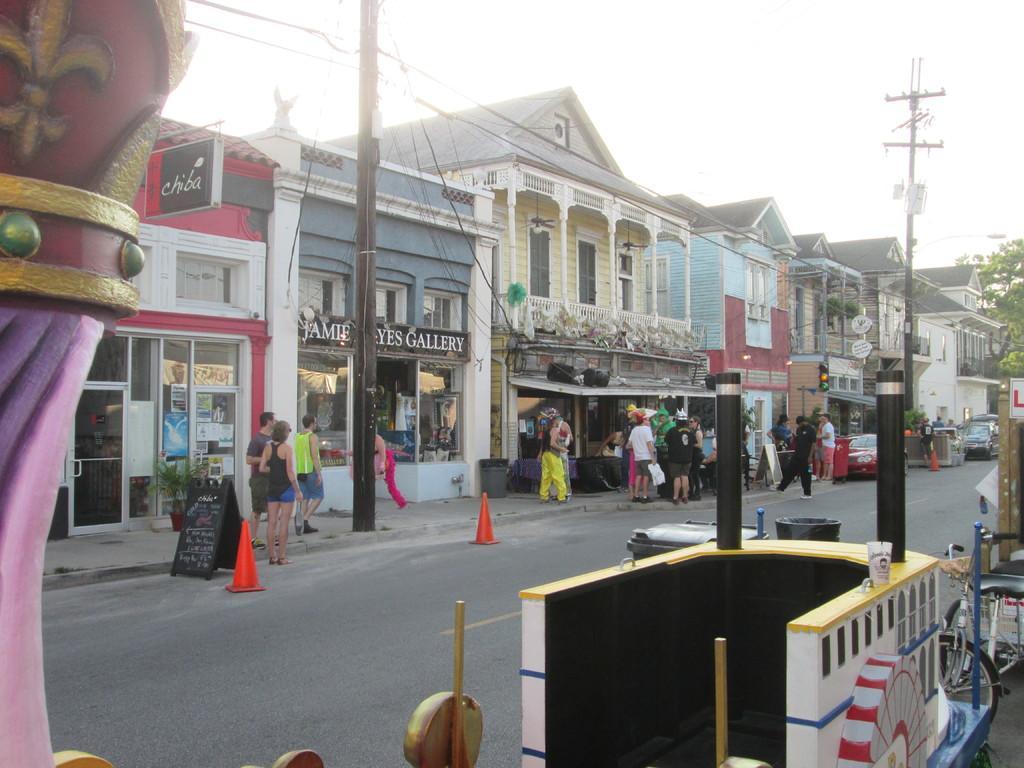In one or two sentences, can you explain what this image depicts? This image is taken outdoors. At the top of the image there is a sky. On the left side of the image there is an architecture. At the bottom of the image there is a vehicle on the road. In the middle of the image there is a road and there are a few buildings and there are many boards with text on them. There are two poles with street lights and wires. There is a tree. Many people are walking on the sidewalk and a few are standing. A few cars are parked on the road. 